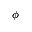<formula> <loc_0><loc_0><loc_500><loc_500>\phi</formula> 